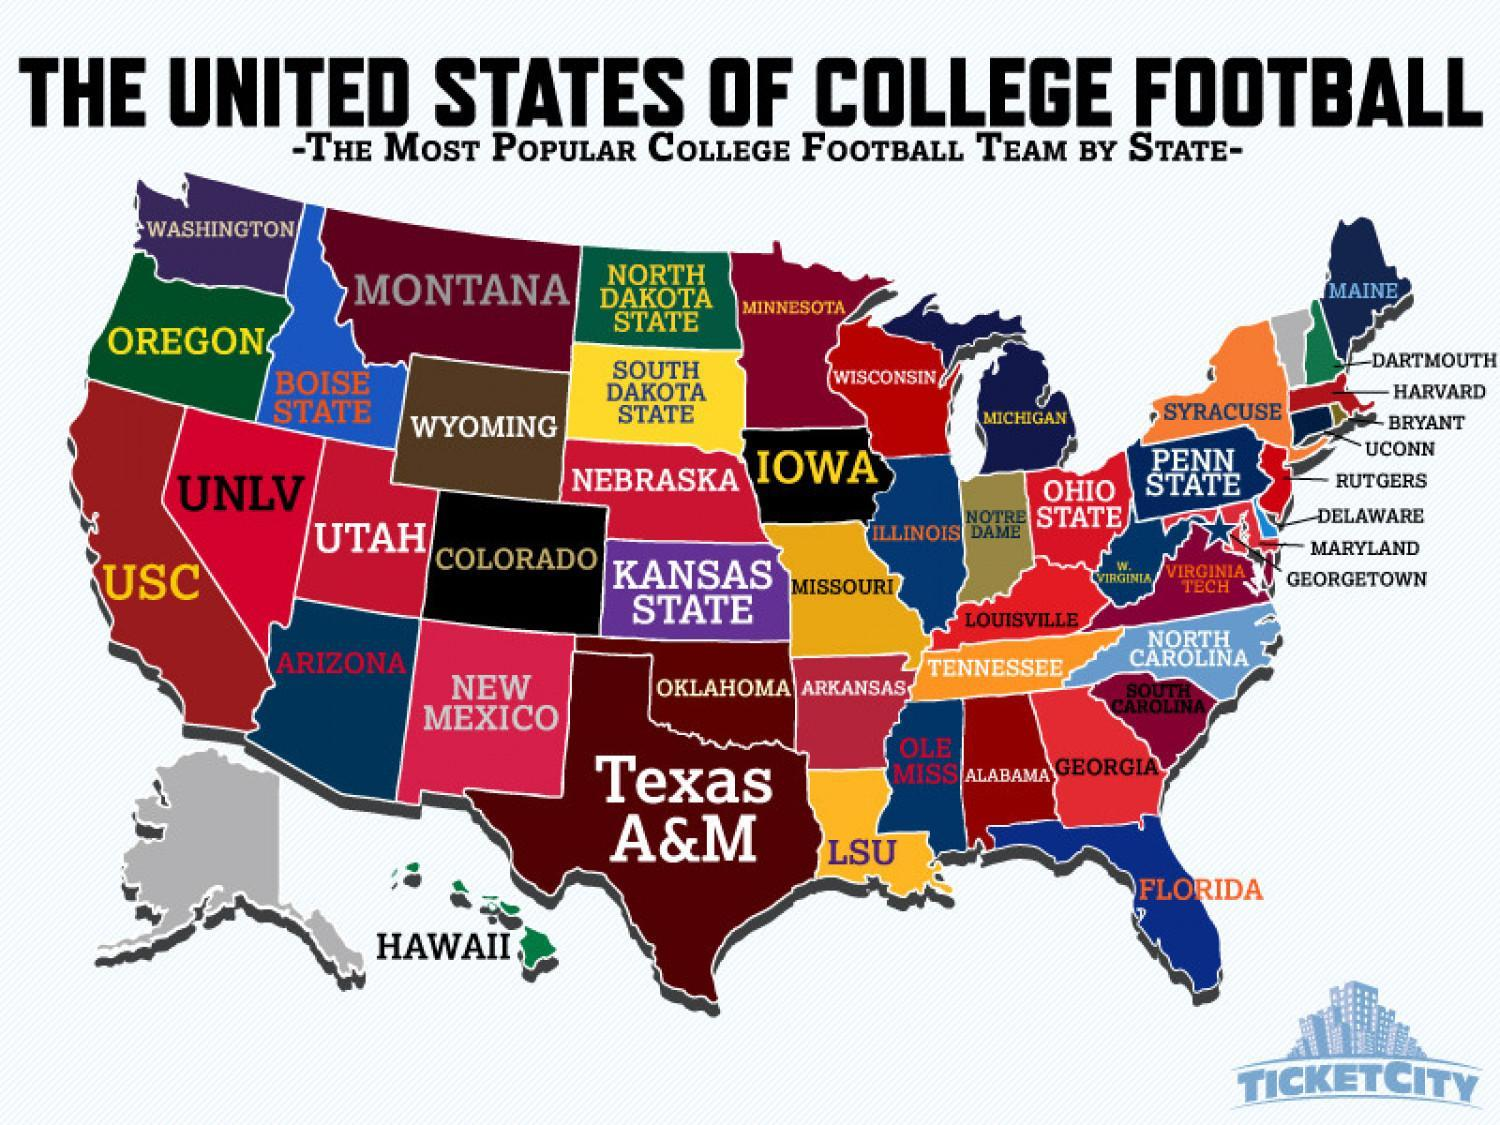Which is the most popular college football team in Nevada?
Answer the question with a short phrase. UNLV Which is the most popular college football team in New Jersey? Rutgers Which is the most popular college football team in Pennsylvania? Penn State Which is the most popular college football team in New York? Syracuse Which is the most popular college football team in Idaho? Boise State Which is the most popular college football team in California? USC Which is the most popular college football team in Connecticut? UCONN Which is the most popular college football team in Massachusetts? Harvard 